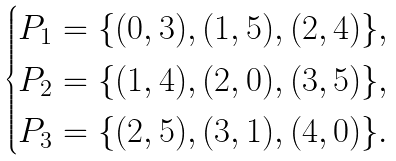<formula> <loc_0><loc_0><loc_500><loc_500>\begin{cases} P _ { 1 } = \{ ( 0 , 3 ) , ( 1 , 5 ) , ( 2 , 4 ) \} , \\ P _ { 2 } = \{ ( 1 , 4 ) , ( 2 , 0 ) , ( 3 , 5 ) \} , \\ P _ { 3 } = \{ ( 2 , 5 ) , ( 3 , 1 ) , ( 4 , 0 ) \} . \end{cases}</formula> 